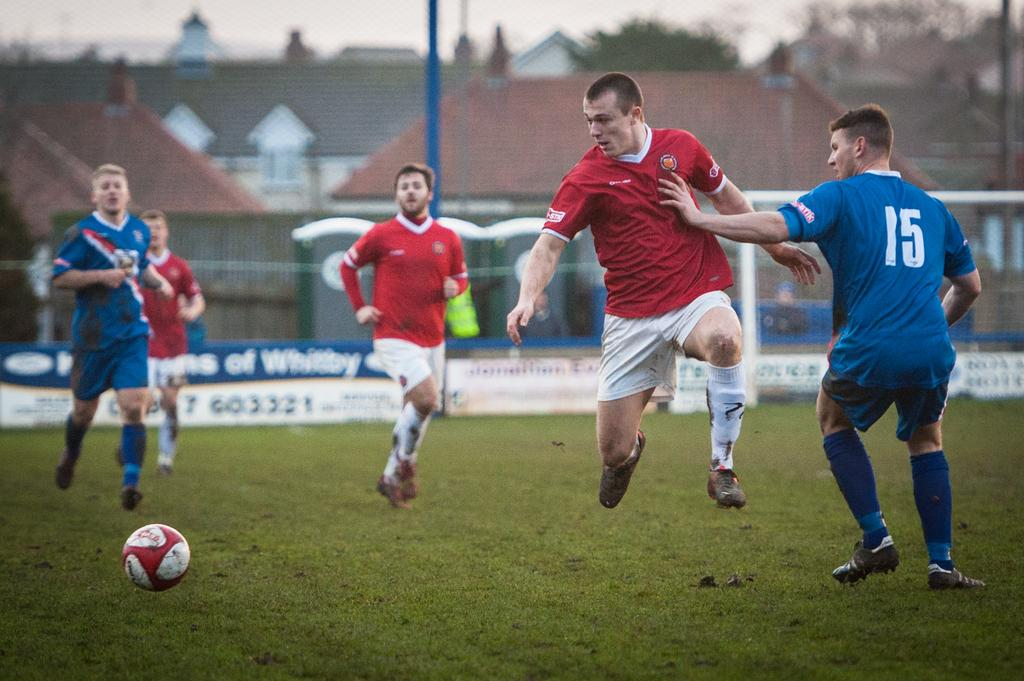<image>
Describe the image concisely. the number 15 is on the back of the jersey of the player 